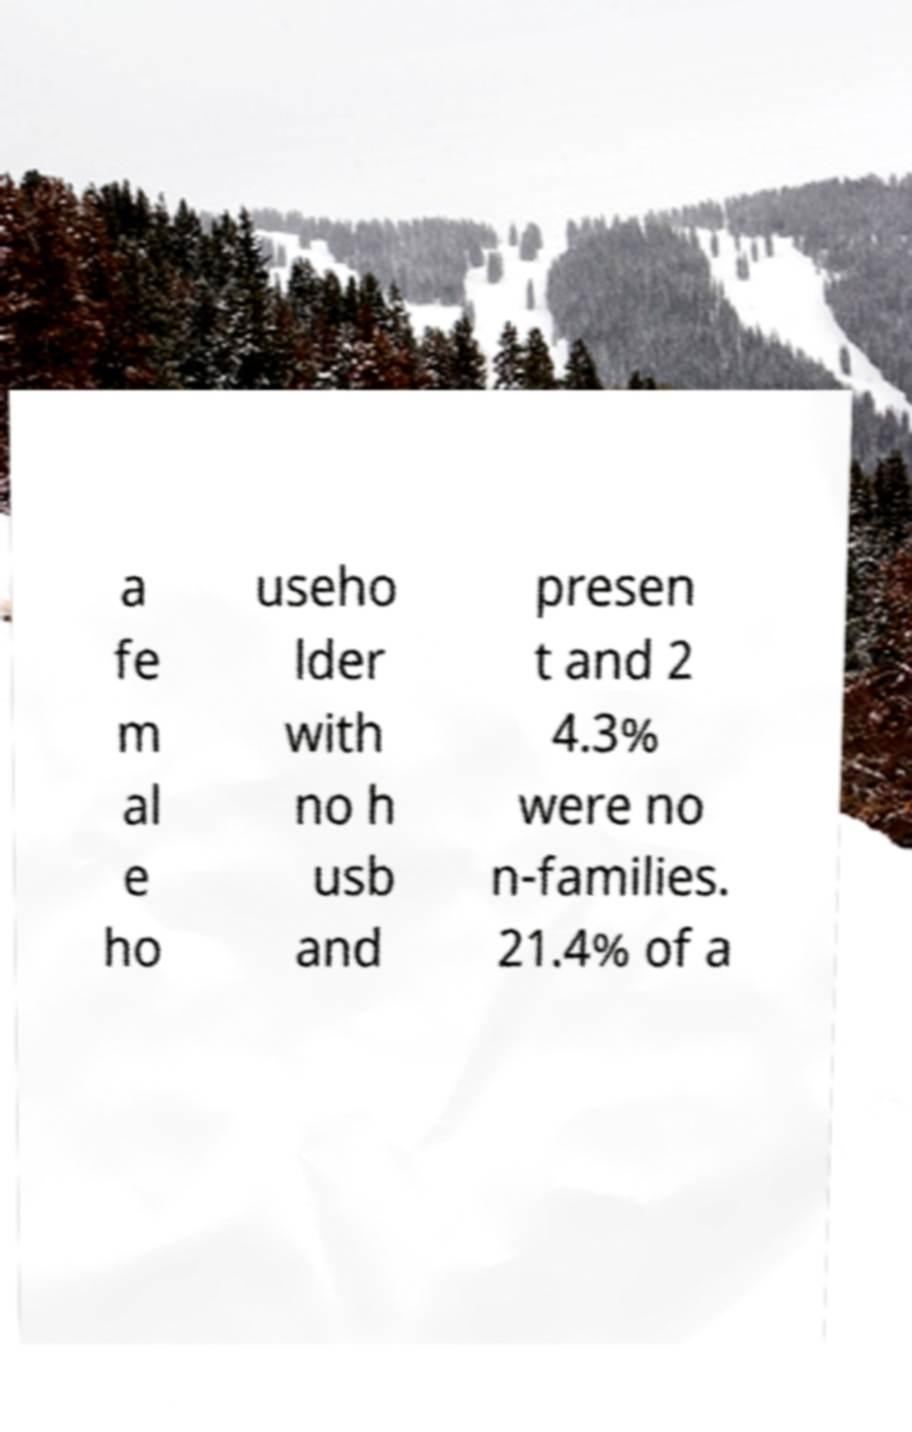Could you assist in decoding the text presented in this image and type it out clearly? a fe m al e ho useho lder with no h usb and presen t and 2 4.3% were no n-families. 21.4% of a 